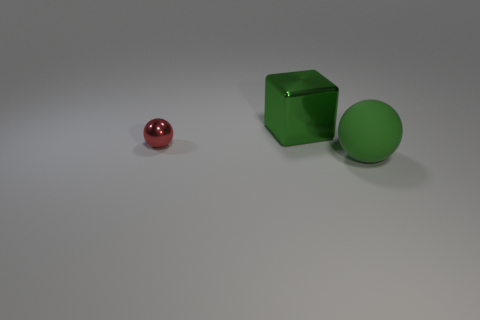Add 2 red things. How many objects exist? 5 Subtract all blocks. How many objects are left? 2 Subtract 0 gray cubes. How many objects are left? 3 Subtract all green rubber things. Subtract all large metal things. How many objects are left? 1 Add 3 tiny red metallic spheres. How many tiny red metallic spheres are left? 4 Add 2 large red shiny things. How many large red shiny things exist? 2 